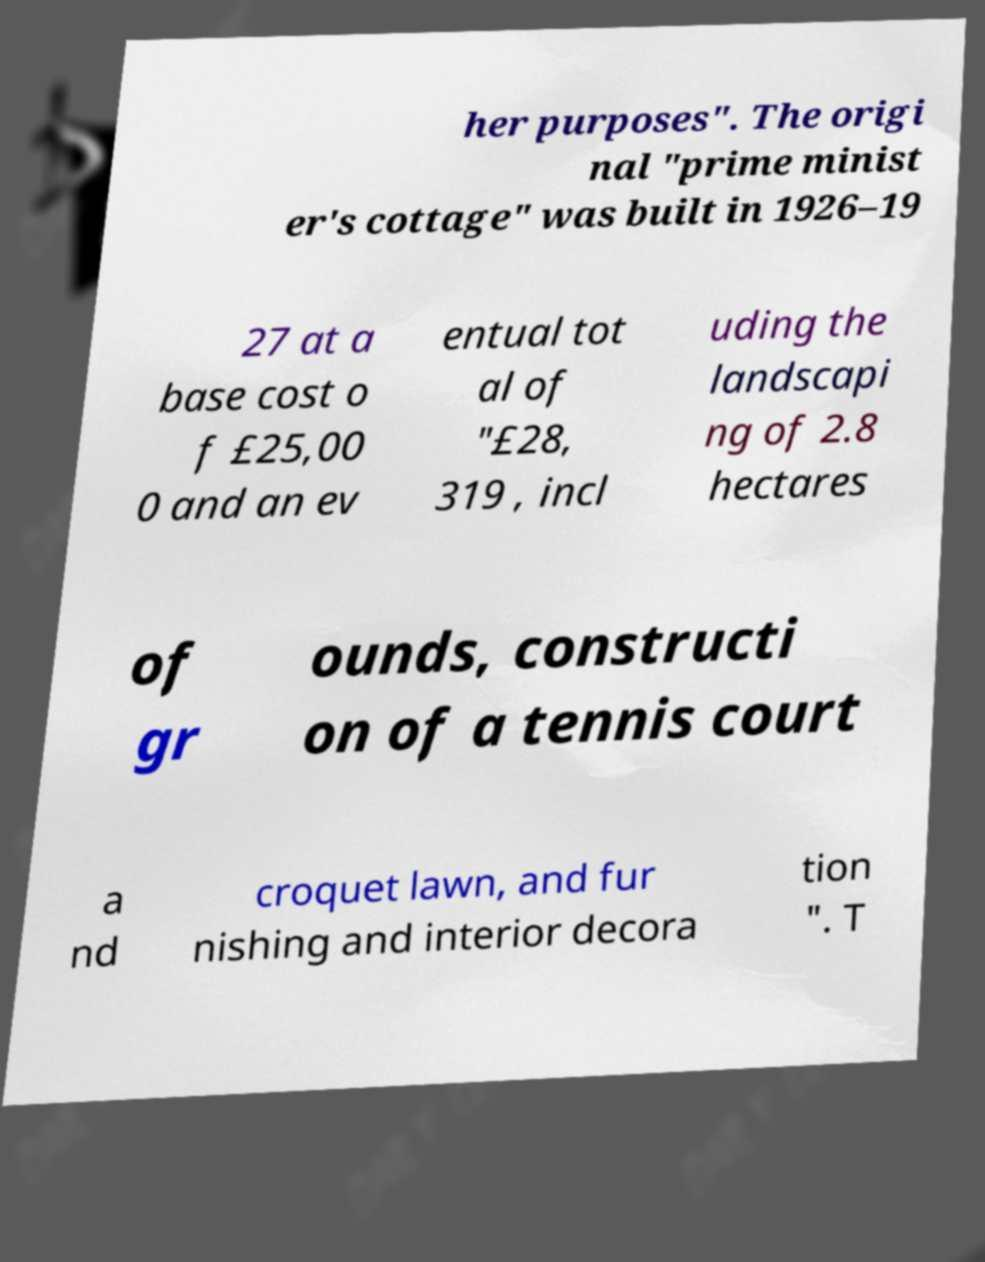Could you assist in decoding the text presented in this image and type it out clearly? her purposes". The origi nal "prime minist er's cottage" was built in 1926–19 27 at a base cost o f £25,00 0 and an ev entual tot al of "£28, 319 , incl uding the landscapi ng of 2.8 hectares of gr ounds, constructi on of a tennis court a nd croquet lawn, and fur nishing and interior decora tion ". T 